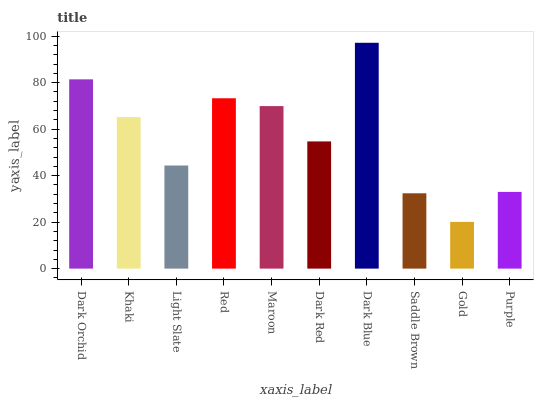Is Gold the minimum?
Answer yes or no. Yes. Is Dark Blue the maximum?
Answer yes or no. Yes. Is Khaki the minimum?
Answer yes or no. No. Is Khaki the maximum?
Answer yes or no. No. Is Dark Orchid greater than Khaki?
Answer yes or no. Yes. Is Khaki less than Dark Orchid?
Answer yes or no. Yes. Is Khaki greater than Dark Orchid?
Answer yes or no. No. Is Dark Orchid less than Khaki?
Answer yes or no. No. Is Khaki the high median?
Answer yes or no. Yes. Is Dark Red the low median?
Answer yes or no. Yes. Is Dark Red the high median?
Answer yes or no. No. Is Dark Orchid the low median?
Answer yes or no. No. 